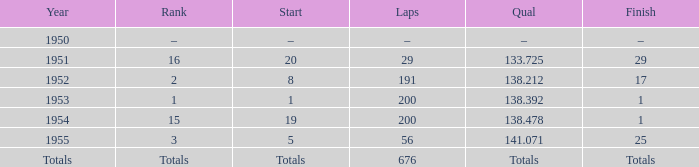What ranking that had a start of 19? 15.0. 